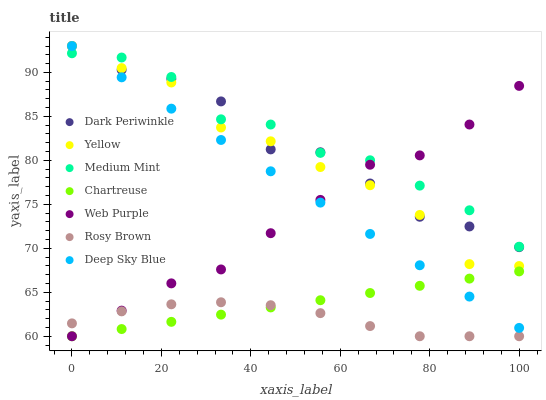Does Rosy Brown have the minimum area under the curve?
Answer yes or no. Yes. Does Medium Mint have the maximum area under the curve?
Answer yes or no. Yes. Does Chartreuse have the minimum area under the curve?
Answer yes or no. No. Does Chartreuse have the maximum area under the curve?
Answer yes or no. No. Is Chartreuse the smoothest?
Answer yes or no. Yes. Is Yellow the roughest?
Answer yes or no. Yes. Is Rosy Brown the smoothest?
Answer yes or no. No. Is Rosy Brown the roughest?
Answer yes or no. No. Does Rosy Brown have the lowest value?
Answer yes or no. Yes. Does Yellow have the lowest value?
Answer yes or no. No. Does Dark Periwinkle have the highest value?
Answer yes or no. Yes. Does Chartreuse have the highest value?
Answer yes or no. No. Is Rosy Brown less than Yellow?
Answer yes or no. Yes. Is Yellow greater than Rosy Brown?
Answer yes or no. Yes. Does Deep Sky Blue intersect Dark Periwinkle?
Answer yes or no. Yes. Is Deep Sky Blue less than Dark Periwinkle?
Answer yes or no. No. Is Deep Sky Blue greater than Dark Periwinkle?
Answer yes or no. No. Does Rosy Brown intersect Yellow?
Answer yes or no. No. 